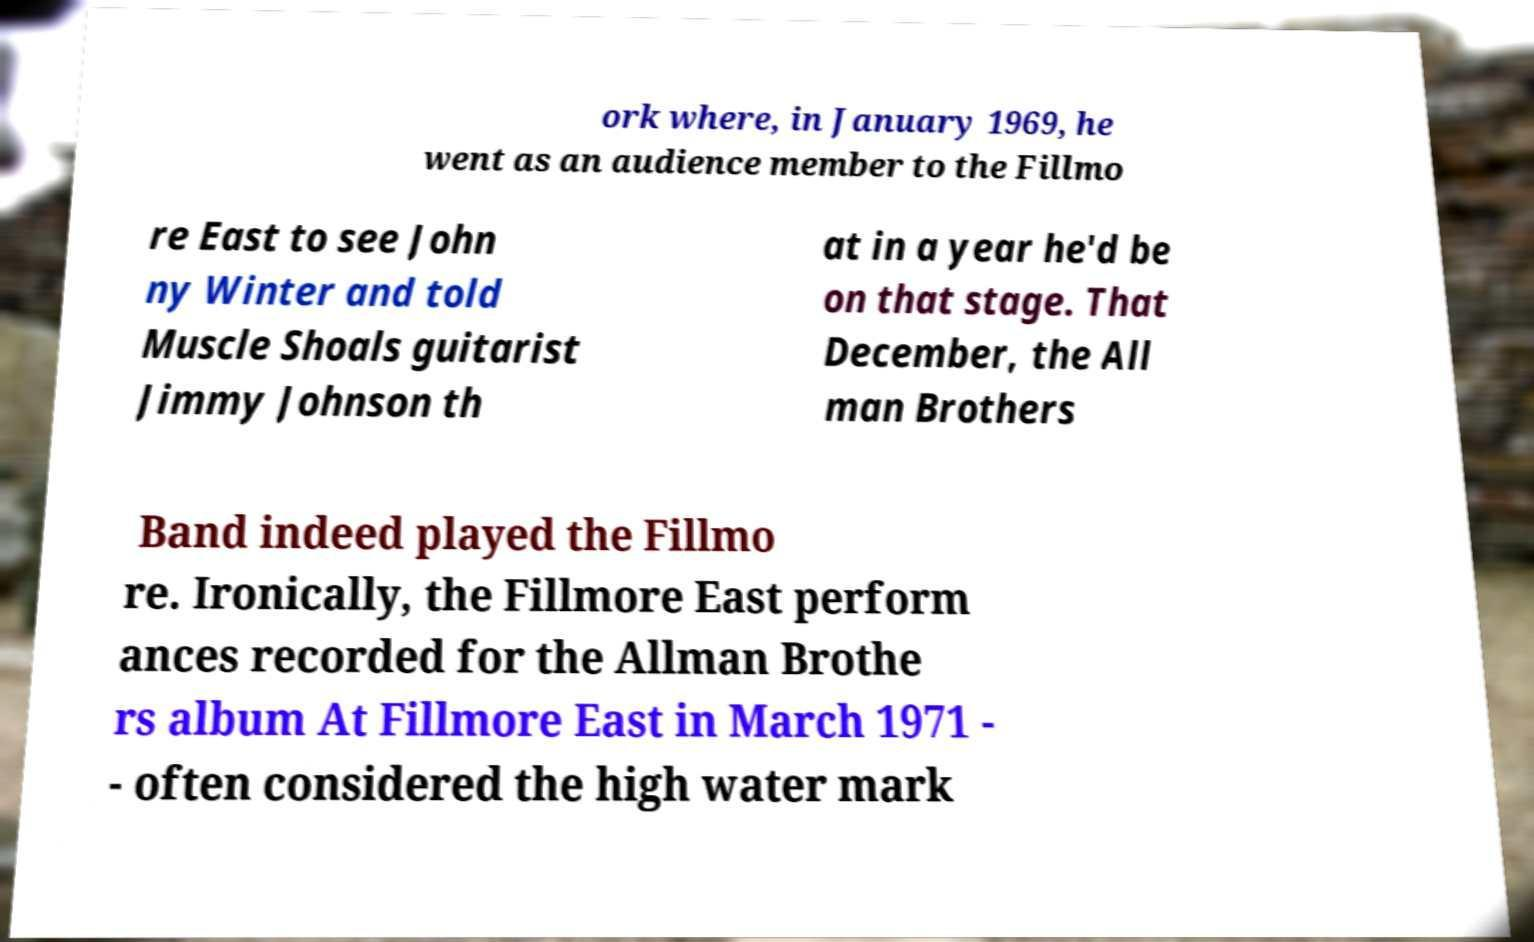What messages or text are displayed in this image? I need them in a readable, typed format. ork where, in January 1969, he went as an audience member to the Fillmo re East to see John ny Winter and told Muscle Shoals guitarist Jimmy Johnson th at in a year he'd be on that stage. That December, the All man Brothers Band indeed played the Fillmo re. Ironically, the Fillmore East perform ances recorded for the Allman Brothe rs album At Fillmore East in March 1971 - - often considered the high water mark 